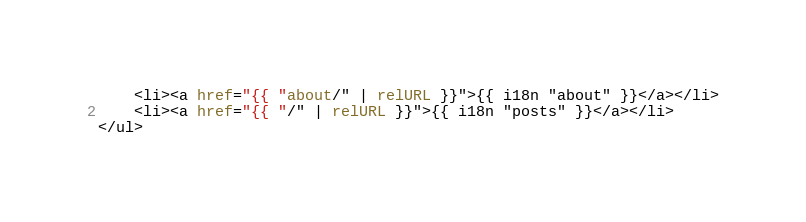<code> <loc_0><loc_0><loc_500><loc_500><_HTML_>    <li><a href="{{ "about/" | relURL }}">{{ i18n "about" }}</a></li>
    <li><a href="{{ "/" | relURL }}">{{ i18n "posts" }}</a></li>
</ul></code> 